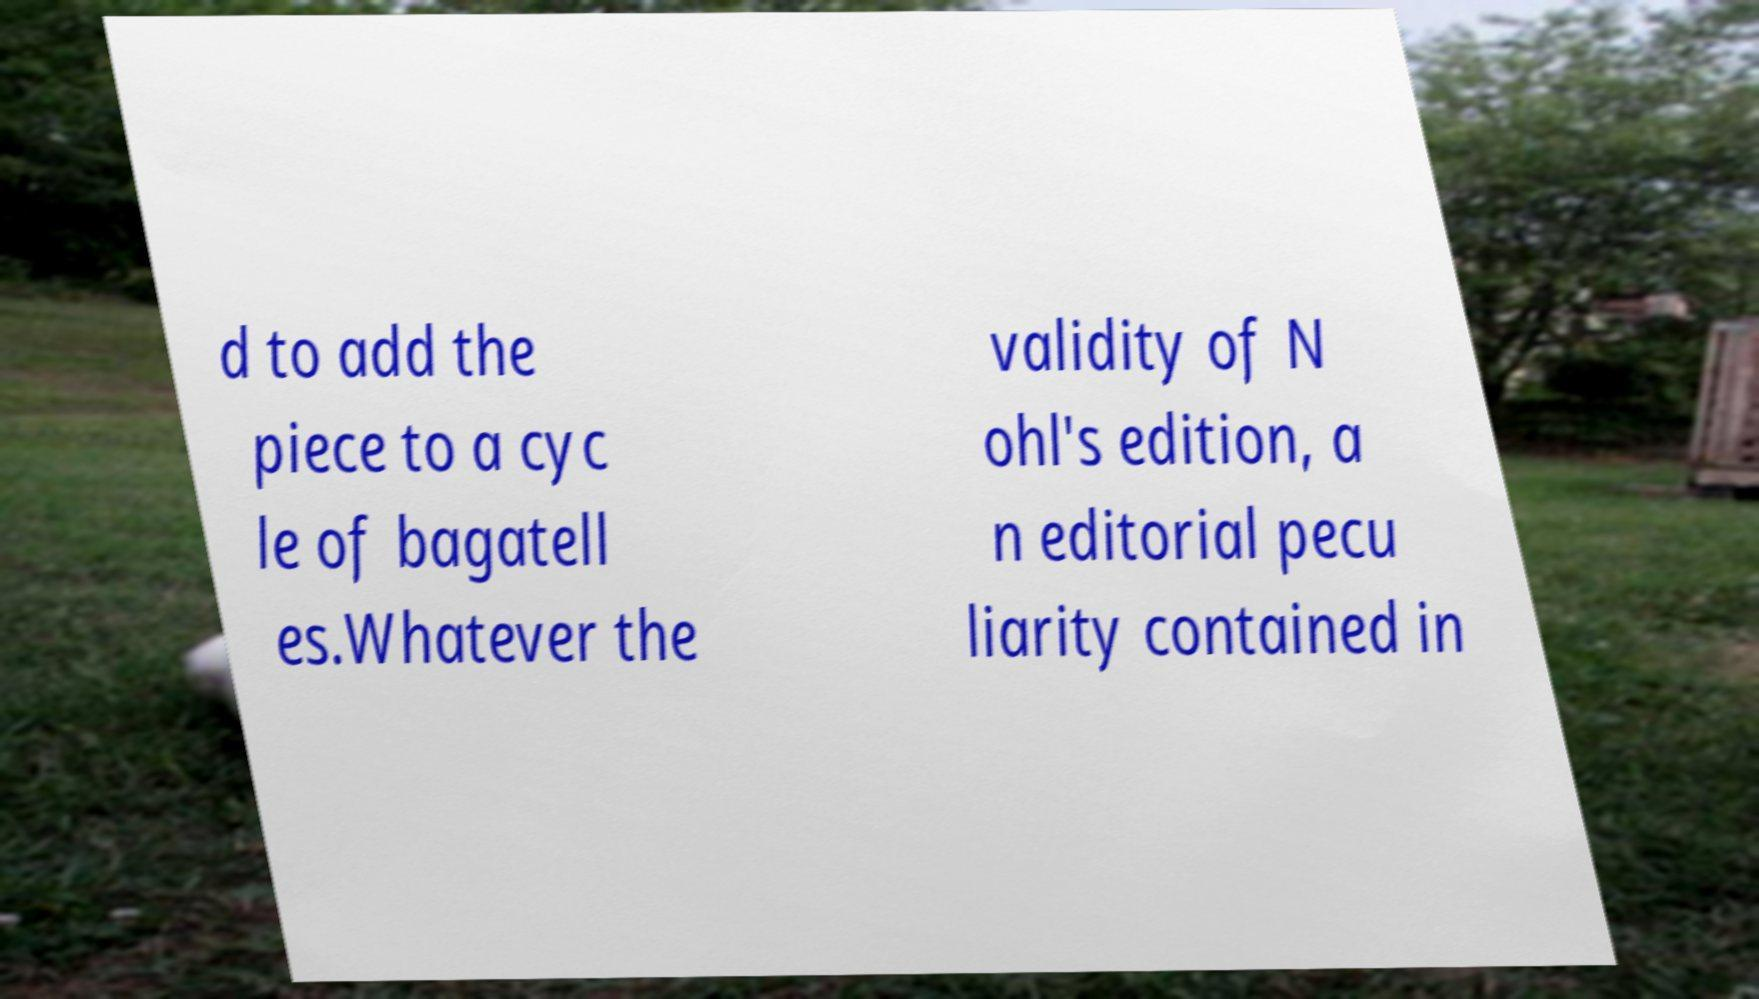Could you extract and type out the text from this image? d to add the piece to a cyc le of bagatell es.Whatever the validity of N ohl's edition, a n editorial pecu liarity contained in 